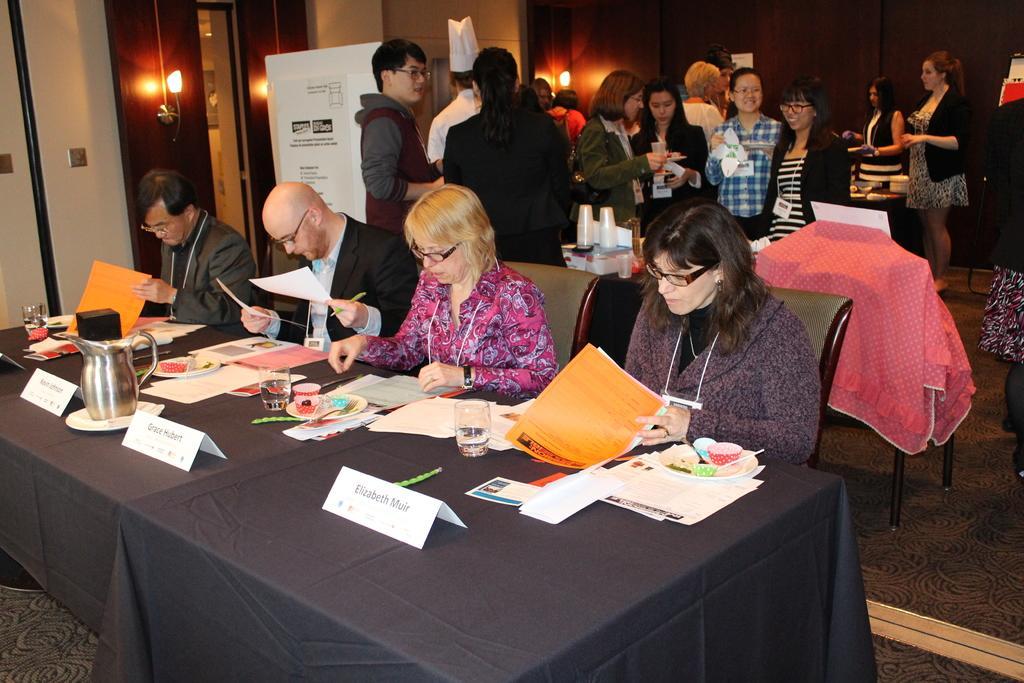How would you summarize this image in a sentence or two? In the image we can see there are people who are sitting on chair and on table there are jug, name plate, glasses, papers, files and in plate there are food items and behind other people who are standing. 